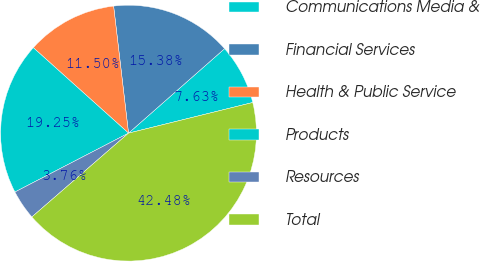Convert chart. <chart><loc_0><loc_0><loc_500><loc_500><pie_chart><fcel>Communications Media &<fcel>Financial Services<fcel>Health & Public Service<fcel>Products<fcel>Resources<fcel>Total<nl><fcel>7.63%<fcel>15.38%<fcel>11.5%<fcel>19.25%<fcel>3.76%<fcel>42.48%<nl></chart> 